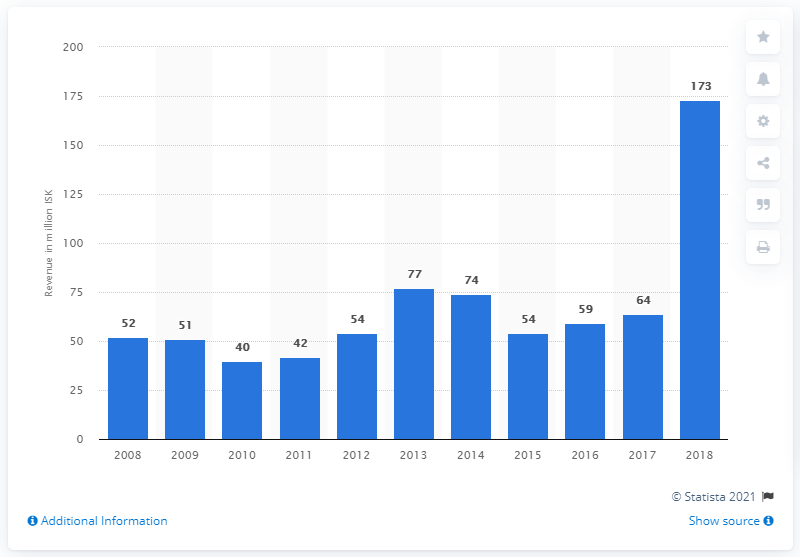Specify some key components in this picture. The value of computer games in Iceland in 2018 was approximately 173... In 2017, computer game revenue in Iceland tripled. 